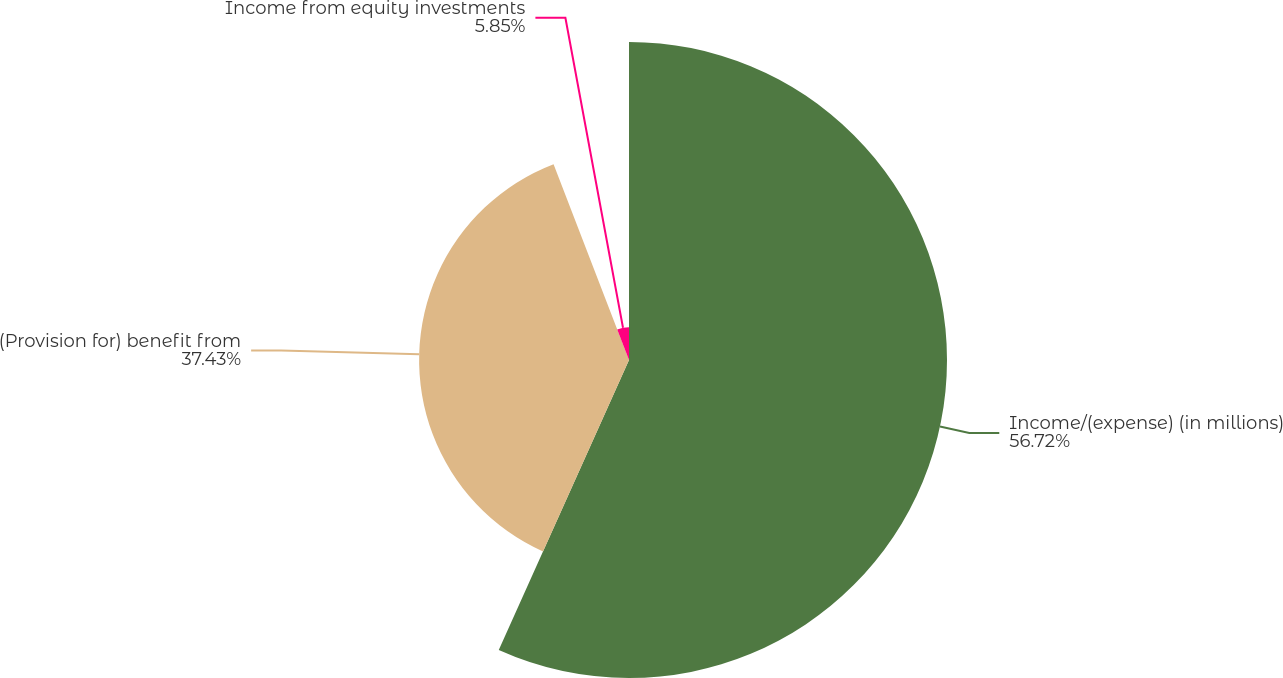<chart> <loc_0><loc_0><loc_500><loc_500><pie_chart><fcel>Income/(expense) (in millions)<fcel>(Provision for) benefit from<fcel>Income from equity investments<nl><fcel>56.71%<fcel>37.43%<fcel>5.85%<nl></chart> 